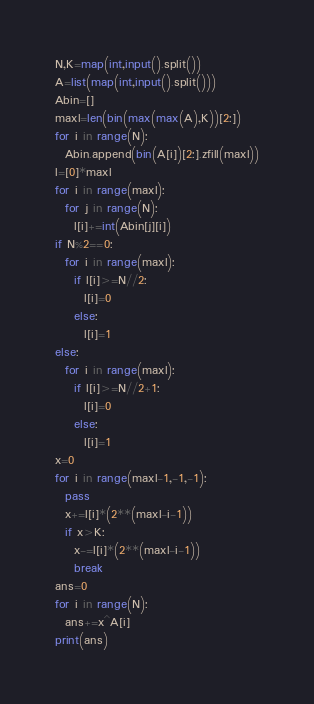Convert code to text. <code><loc_0><loc_0><loc_500><loc_500><_Python_>N,K=map(int,input().split())
A=list(map(int,input().split()))
Abin=[]
maxl=len(bin(max(max(A),K))[2:])
for i in range(N):
  Abin.append(bin(A[i])[2:].zfill(maxl))
l=[0]*maxl
for i in range(maxl):
  for j in range(N):
    l[i]+=int(Abin[j][i])
if N%2==0:
  for i in range(maxl):
    if l[i]>=N//2:
      l[i]=0
    else:
      l[i]=1
else:
  for i in range(maxl):
    if l[i]>=N//2+1:
      l[i]=0
    else:
      l[i]=1
x=0
for i in range(maxl-1,-1,-1):
  pass
  x+=l[i]*(2**(maxl-i-1))
  if x>K:
    x-=l[i]*(2**(maxl-i-1))
    break
ans=0
for i in range(N):
  ans+=x^A[i]
print(ans)</code> 